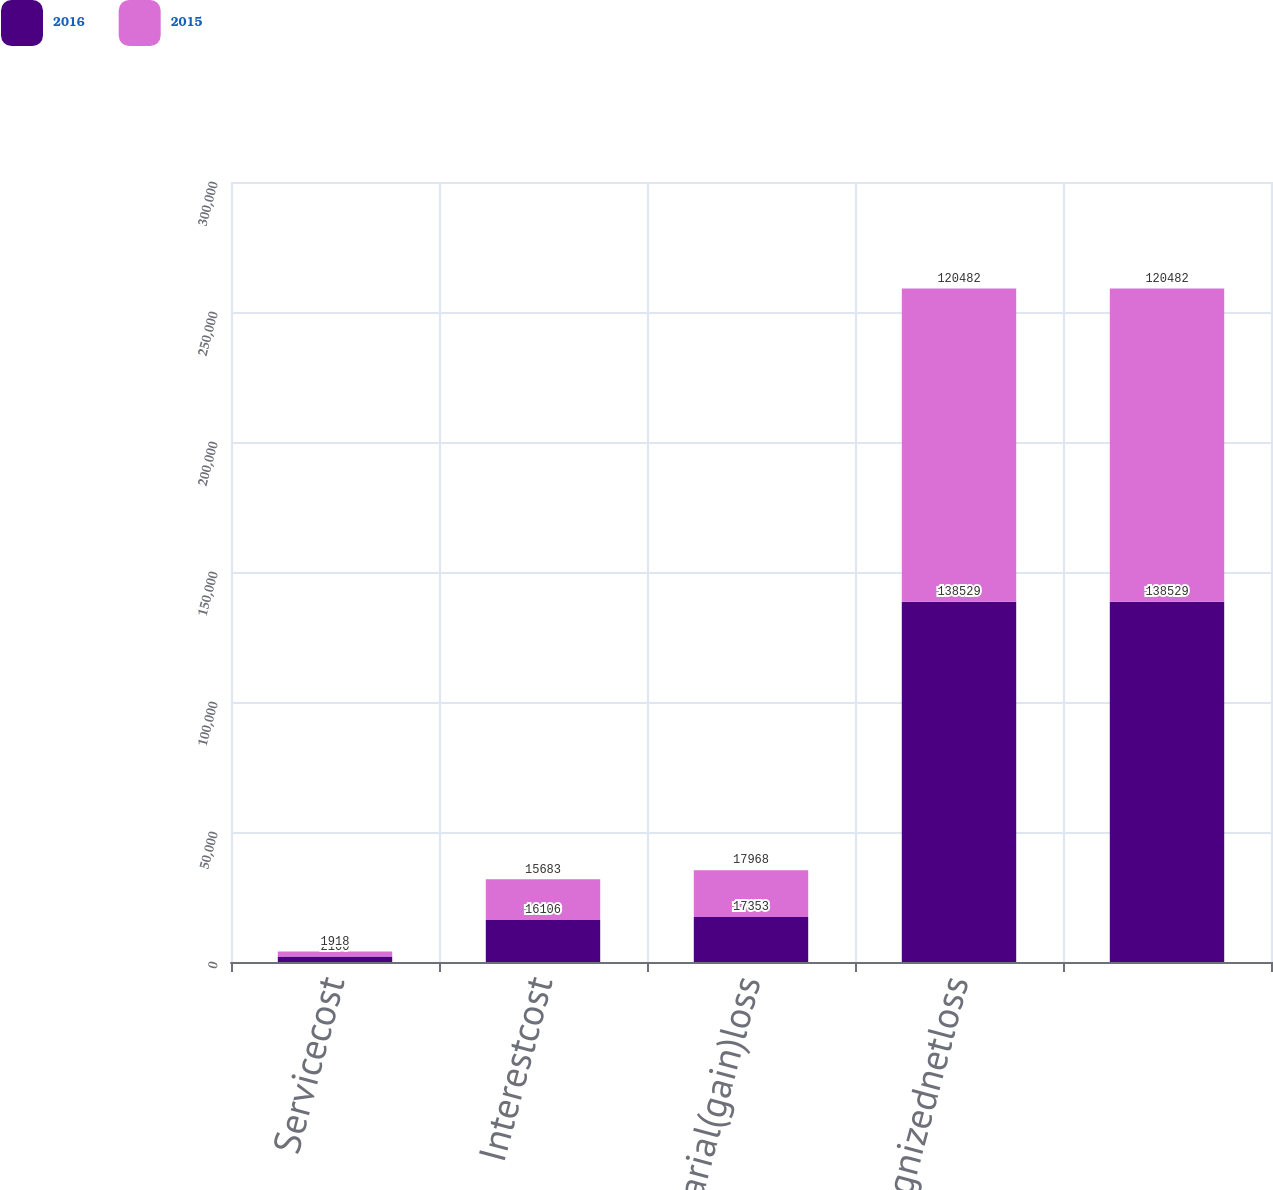Convert chart to OTSL. <chart><loc_0><loc_0><loc_500><loc_500><stacked_bar_chart><ecel><fcel>Servicecost<fcel>Interestcost<fcel>Actuarial(gain)loss<fcel>Unrecognizednetloss<fcel>Unnamed: 5<nl><fcel>2016<fcel>2100<fcel>16106<fcel>17353<fcel>138529<fcel>138529<nl><fcel>2015<fcel>1918<fcel>15683<fcel>17968<fcel>120482<fcel>120482<nl></chart> 